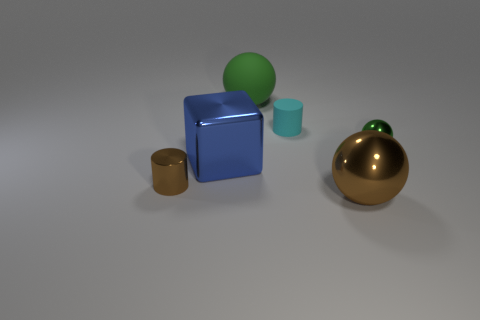Add 4 small green cylinders. How many objects exist? 10 Subtract all blocks. How many objects are left? 5 Add 5 brown metallic cylinders. How many brown metallic cylinders are left? 6 Add 2 tiny shiny objects. How many tiny shiny objects exist? 4 Subtract 0 purple spheres. How many objects are left? 6 Subtract all shiny objects. Subtract all small cyan matte cylinders. How many objects are left? 1 